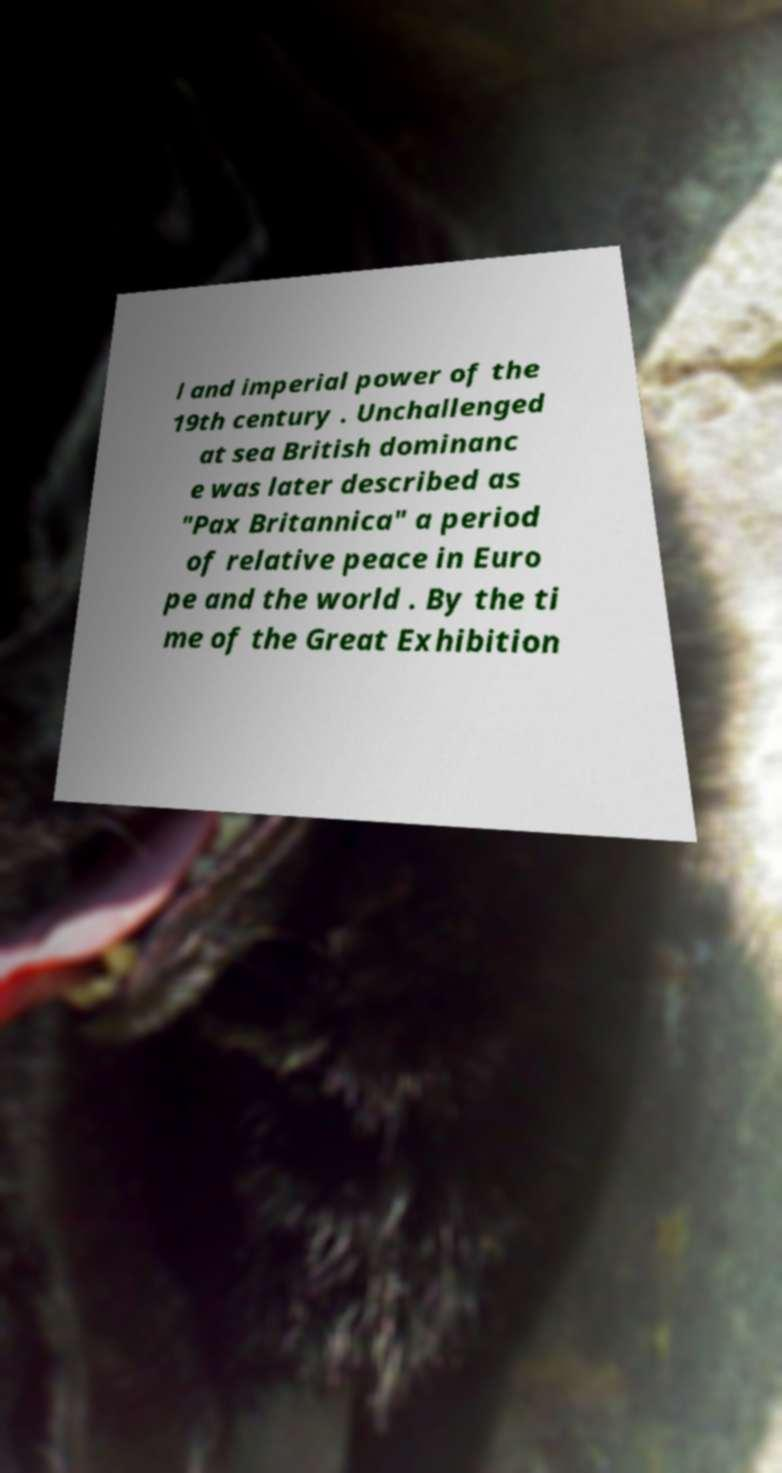For documentation purposes, I need the text within this image transcribed. Could you provide that? l and imperial power of the 19th century . Unchallenged at sea British dominanc e was later described as "Pax Britannica" a period of relative peace in Euro pe and the world . By the ti me of the Great Exhibition 